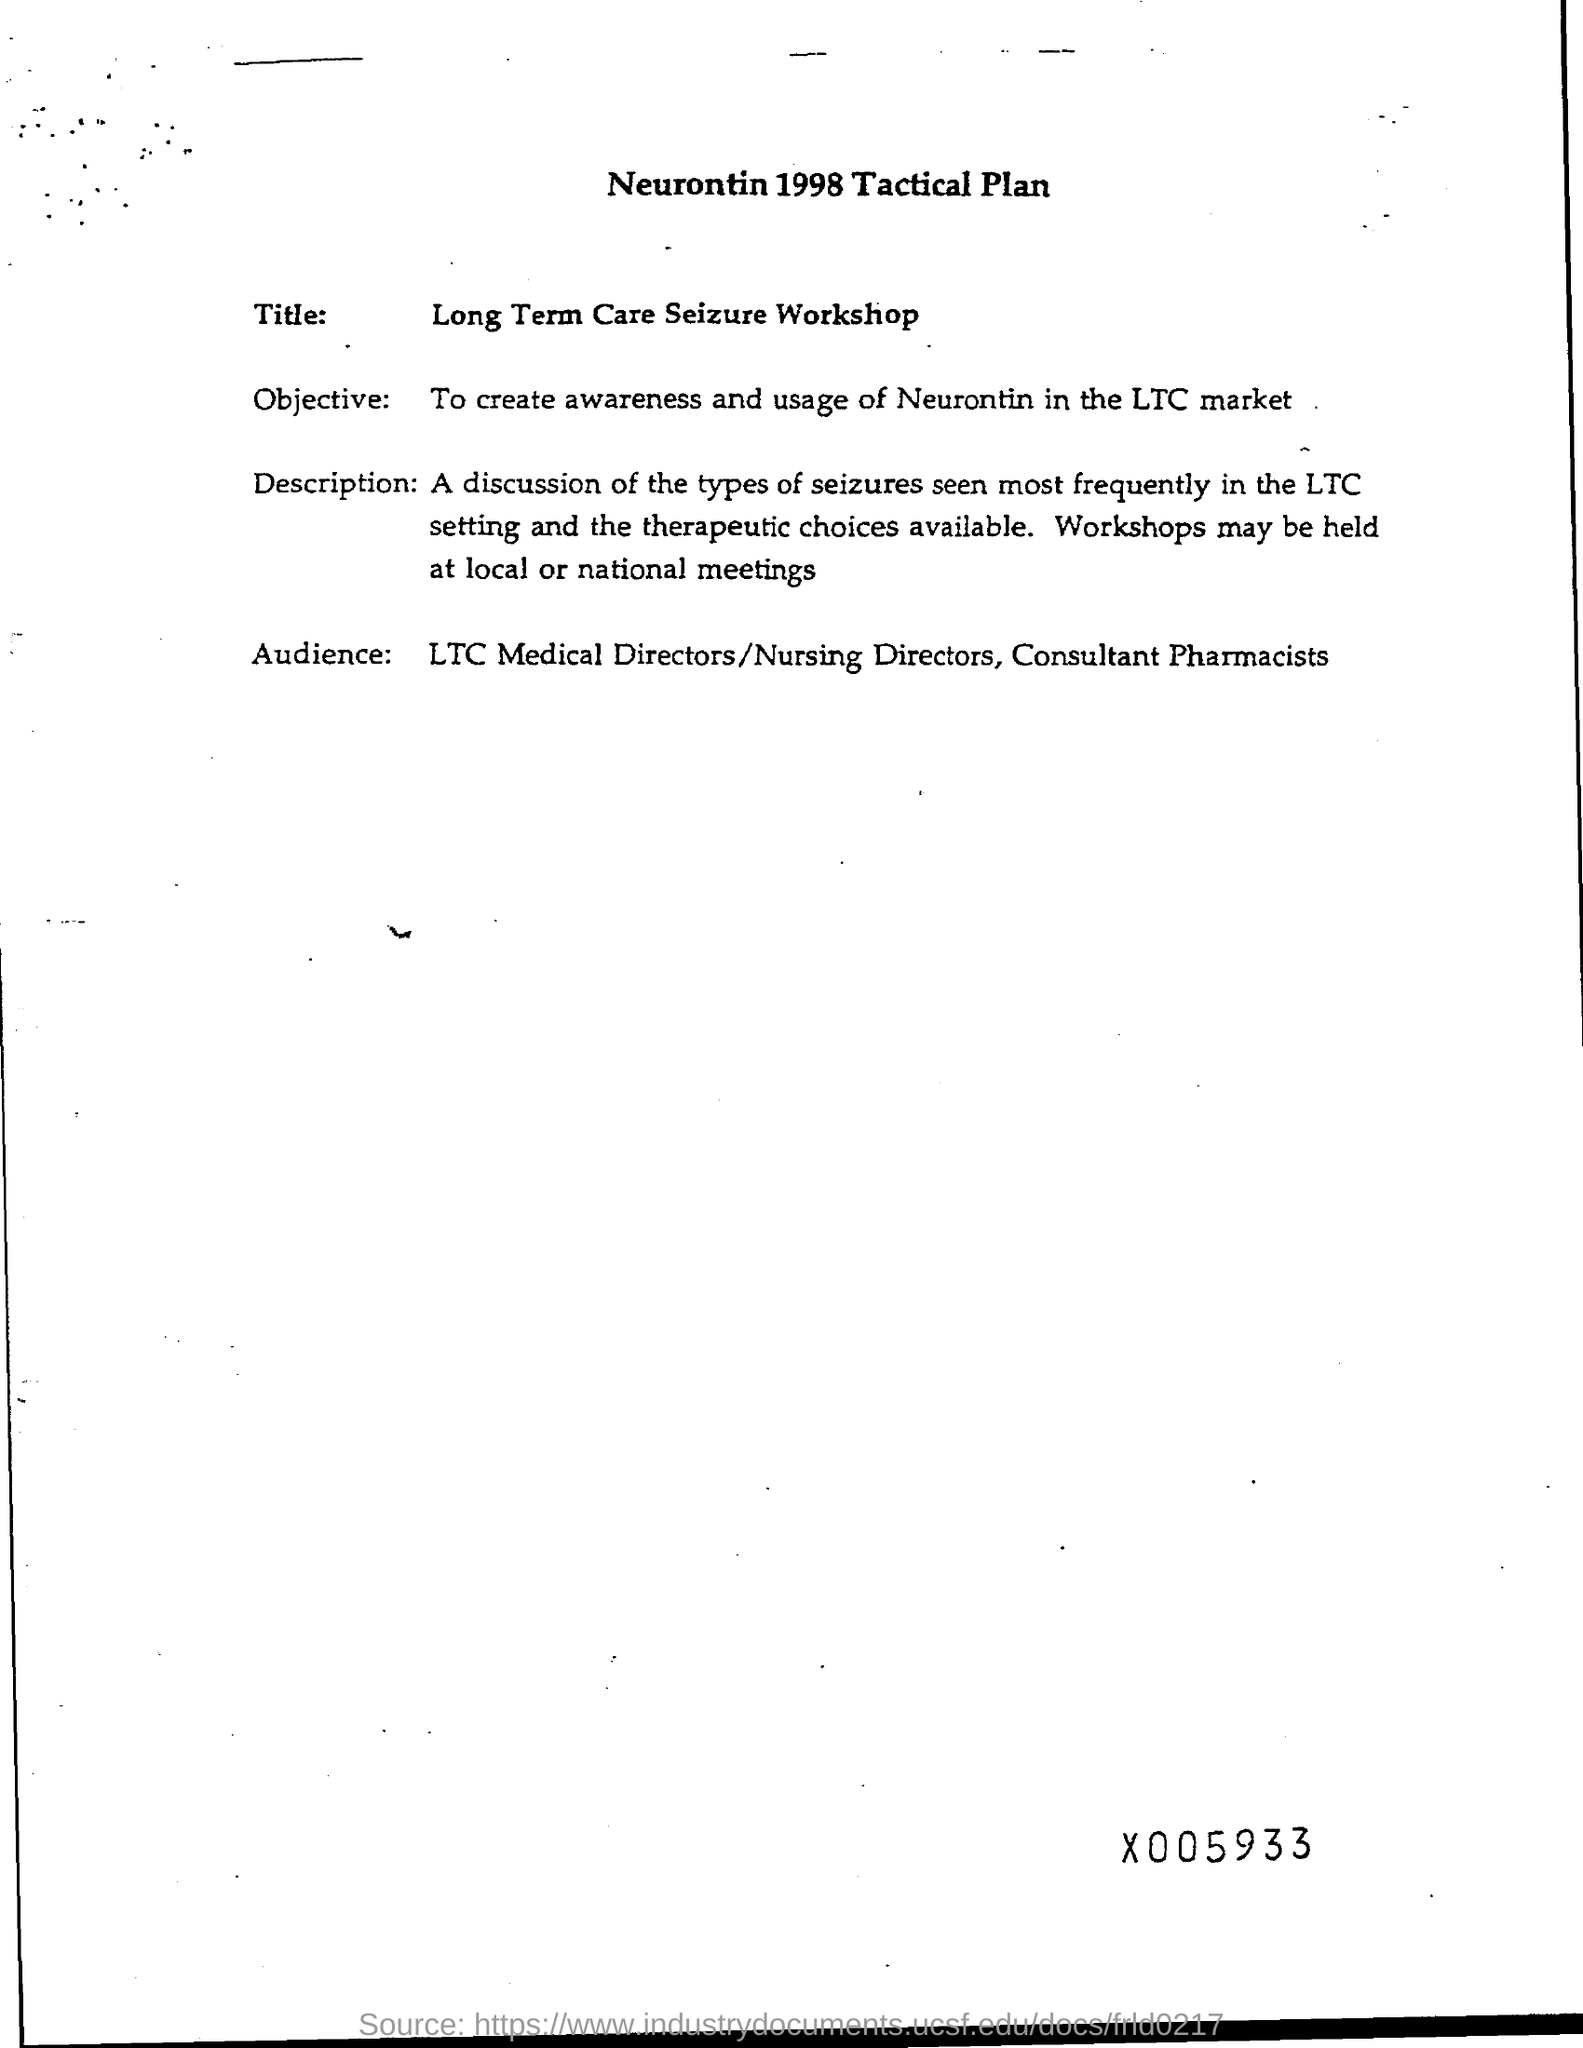To create awareness and usage of Neurontin where?
Give a very brief answer. LTC market. 